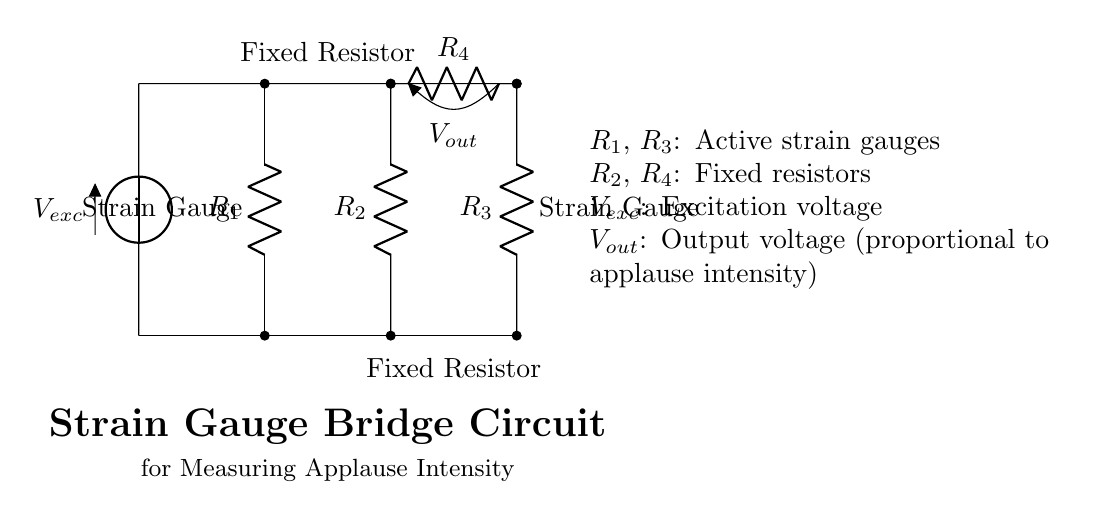What is the excitation voltage in the circuit? The excitation voltage is represented by the source labeled V_exc in the circuit diagram, which provides power to the bridge.
Answer: V_exc What are the types of resistors in the bridge circuit? In the bridge circuit, R_1 and R_3 are active strain gauges, while R_2 and R_4 are fixed resistors. These components play different roles in the measurement process.
Answer: Strain gauges and fixed resistors How many resistors are in the circuit? There are four resistors in total, which are arranged in the bridge configuration as shown in the circuit.
Answer: Four What is the purpose of the output voltage in this circuit? The output voltage, labeled V_out, is measured to determine the intensity of applause, as it varies based on the resistance changes in the strain gauges when applauses occur.
Answer: Measure applause intensity How do the strain gauges function within the bridge circuit? The strain gauges R_1 and R_3 change their resistance in response to mechanical strain caused by the applause, leading to a balanced or unbalanced bridge, which affects the output voltage.
Answer: Detect mechanical strain What happens if one of the resistors in the bridge circuit fails? If one of the resistors fails, it will disrupt the balance of the bridge circuit, resulting in an inaccurate output voltage reading, which can misrepresent the applause intensity.
Answer: Disrupts balance 